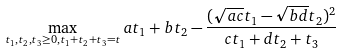Convert formula to latex. <formula><loc_0><loc_0><loc_500><loc_500>\max _ { t _ { 1 } , t _ { 2 } , t _ { 3 } \geq 0 , t _ { 1 } + t _ { 2 } + t _ { 3 } = t } a t _ { 1 } + b t _ { 2 } - \frac { ( \sqrt { a c } t _ { 1 } - \sqrt { b d } t _ { 2 } ) ^ { 2 } } { c t _ { 1 } + d t _ { 2 } + t _ { 3 } }</formula> 